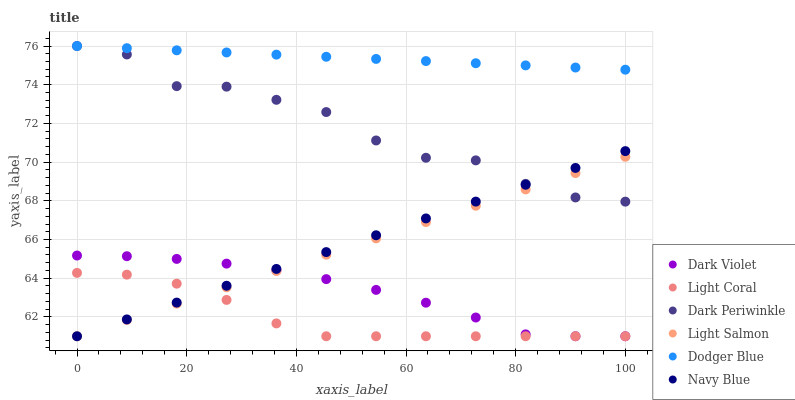Does Light Coral have the minimum area under the curve?
Answer yes or no. Yes. Does Dodger Blue have the maximum area under the curve?
Answer yes or no. Yes. Does Navy Blue have the minimum area under the curve?
Answer yes or no. No. Does Navy Blue have the maximum area under the curve?
Answer yes or no. No. Is Navy Blue the smoothest?
Answer yes or no. Yes. Is Dark Periwinkle the roughest?
Answer yes or no. Yes. Is Dark Violet the smoothest?
Answer yes or no. No. Is Dark Violet the roughest?
Answer yes or no. No. Does Light Salmon have the lowest value?
Answer yes or no. Yes. Does Dodger Blue have the lowest value?
Answer yes or no. No. Does Dark Periwinkle have the highest value?
Answer yes or no. Yes. Does Navy Blue have the highest value?
Answer yes or no. No. Is Light Salmon less than Dodger Blue?
Answer yes or no. Yes. Is Dark Periwinkle greater than Dark Violet?
Answer yes or no. Yes. Does Light Salmon intersect Dark Periwinkle?
Answer yes or no. Yes. Is Light Salmon less than Dark Periwinkle?
Answer yes or no. No. Is Light Salmon greater than Dark Periwinkle?
Answer yes or no. No. Does Light Salmon intersect Dodger Blue?
Answer yes or no. No. 